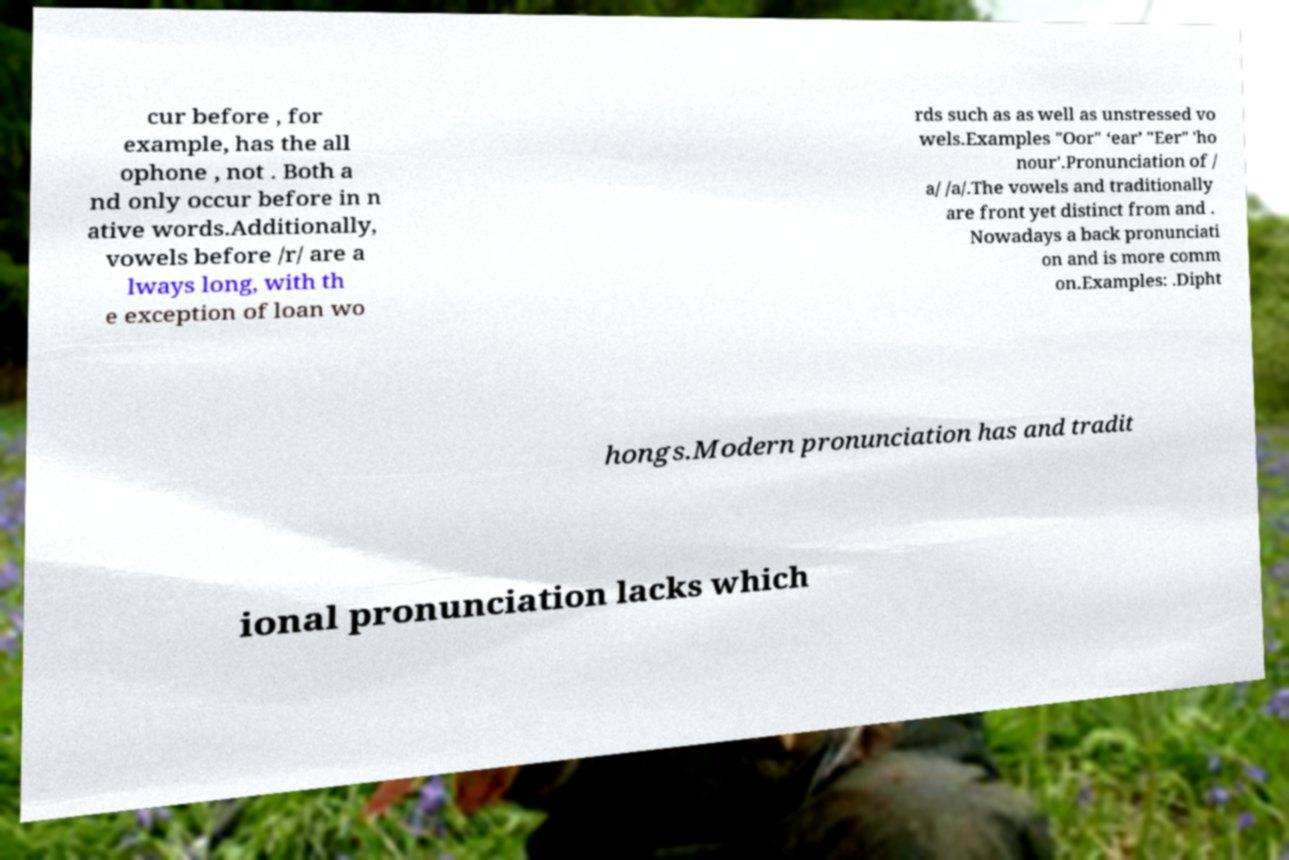What messages or text are displayed in this image? I need them in a readable, typed format. cur before , for example, has the all ophone , not . Both a nd only occur before in n ative words.Additionally, vowels before /r/ are a lways long, with th e exception of loan wo rds such as as well as unstressed vo wels.Examples "Oor" ‘ear’ "Eer" 'ho nour'.Pronunciation of / a/ /a/.The vowels and traditionally are front yet distinct from and . Nowadays a back pronunciati on and is more comm on.Examples: .Dipht hongs.Modern pronunciation has and tradit ional pronunciation lacks which 